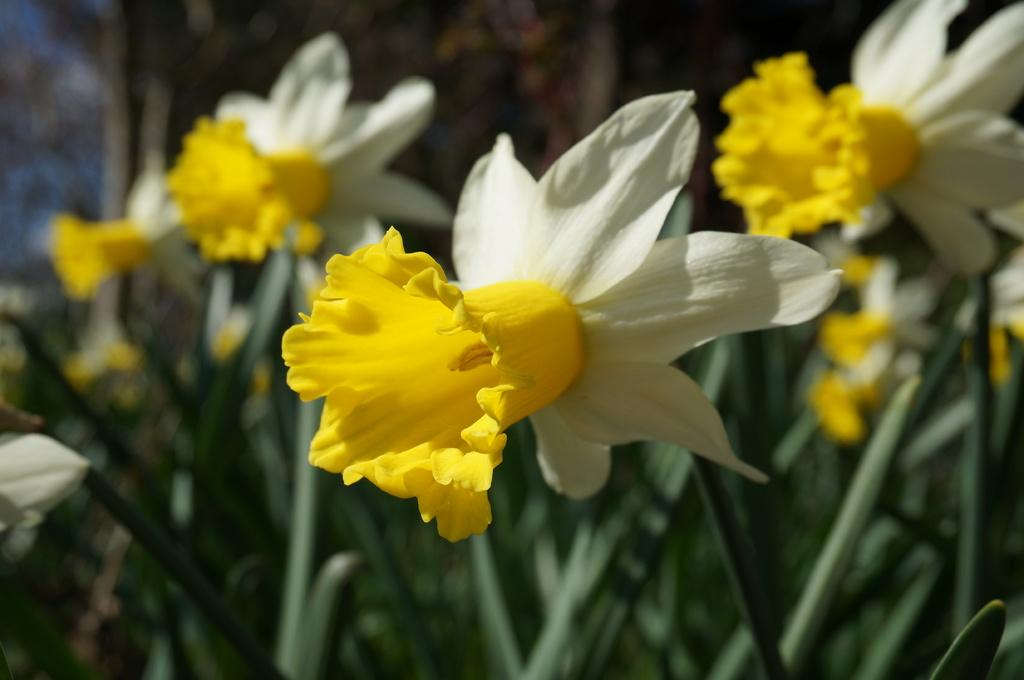What type of flower plants are visible in the image? There are yellow and white flower plants in the image. Can you describe the background of the image? The background of the image is blurred. What is the name of the person who is riding the bike in the image? There are no bikes or people present in the image, so it is not possible to determine the name of a person riding a bike. 